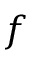Convert formula to latex. <formula><loc_0><loc_0><loc_500><loc_500>f</formula> 